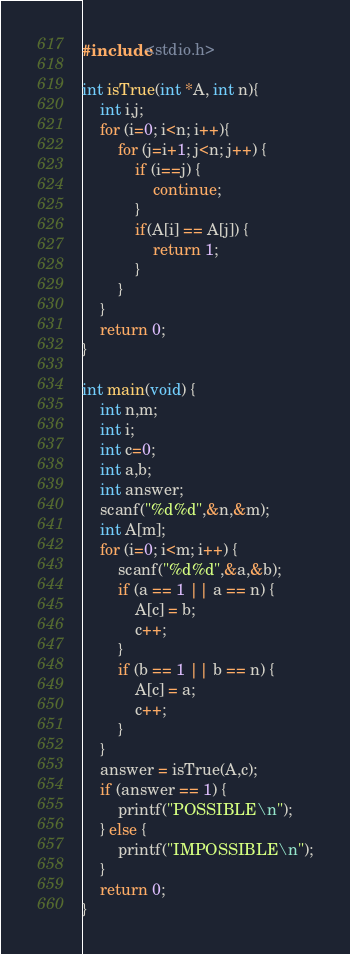Convert code to text. <code><loc_0><loc_0><loc_500><loc_500><_C_>#include<stdio.h>

int isTrue(int *A, int n){
    int i,j;
    for (i=0; i<n; i++){
        for (j=i+1; j<n; j++) {
            if (i==j) {
                continue;
            }
            if(A[i] == A[j]) {
                return 1;
            }
        }
    }
    return 0;
}

int main(void) {
    int n,m;
    int i;
    int c=0;
    int a,b;
    int answer;
    scanf("%d%d",&n,&m);
    int A[m];
    for (i=0; i<m; i++) {
        scanf("%d%d",&a,&b);
        if (a == 1 || a == n) {
            A[c] = b;
            c++;
        }
        if (b == 1 || b == n) {
            A[c] = a;
            c++;
        }
    }
    answer = isTrue(A,c);
    if (answer == 1) {
        printf("POSSIBLE\n");
    } else {
        printf("IMPOSSIBLE\n");
    }
    return 0;
}
</code> 